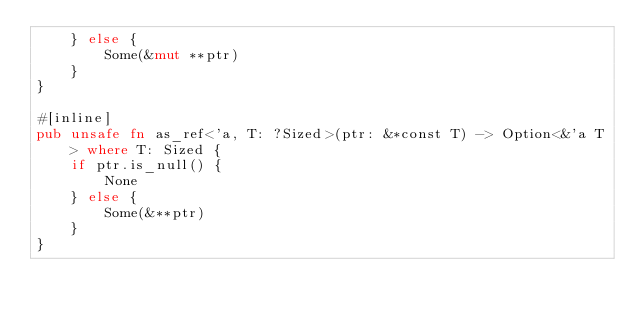Convert code to text. <code><loc_0><loc_0><loc_500><loc_500><_Rust_>    } else {
        Some(&mut **ptr)
    }
}

#[inline]
pub unsafe fn as_ref<'a, T: ?Sized>(ptr: &*const T) -> Option<&'a T> where T: Sized {
    if ptr.is_null() {
        None
    } else {
        Some(&**ptr)
    }
}
</code> 